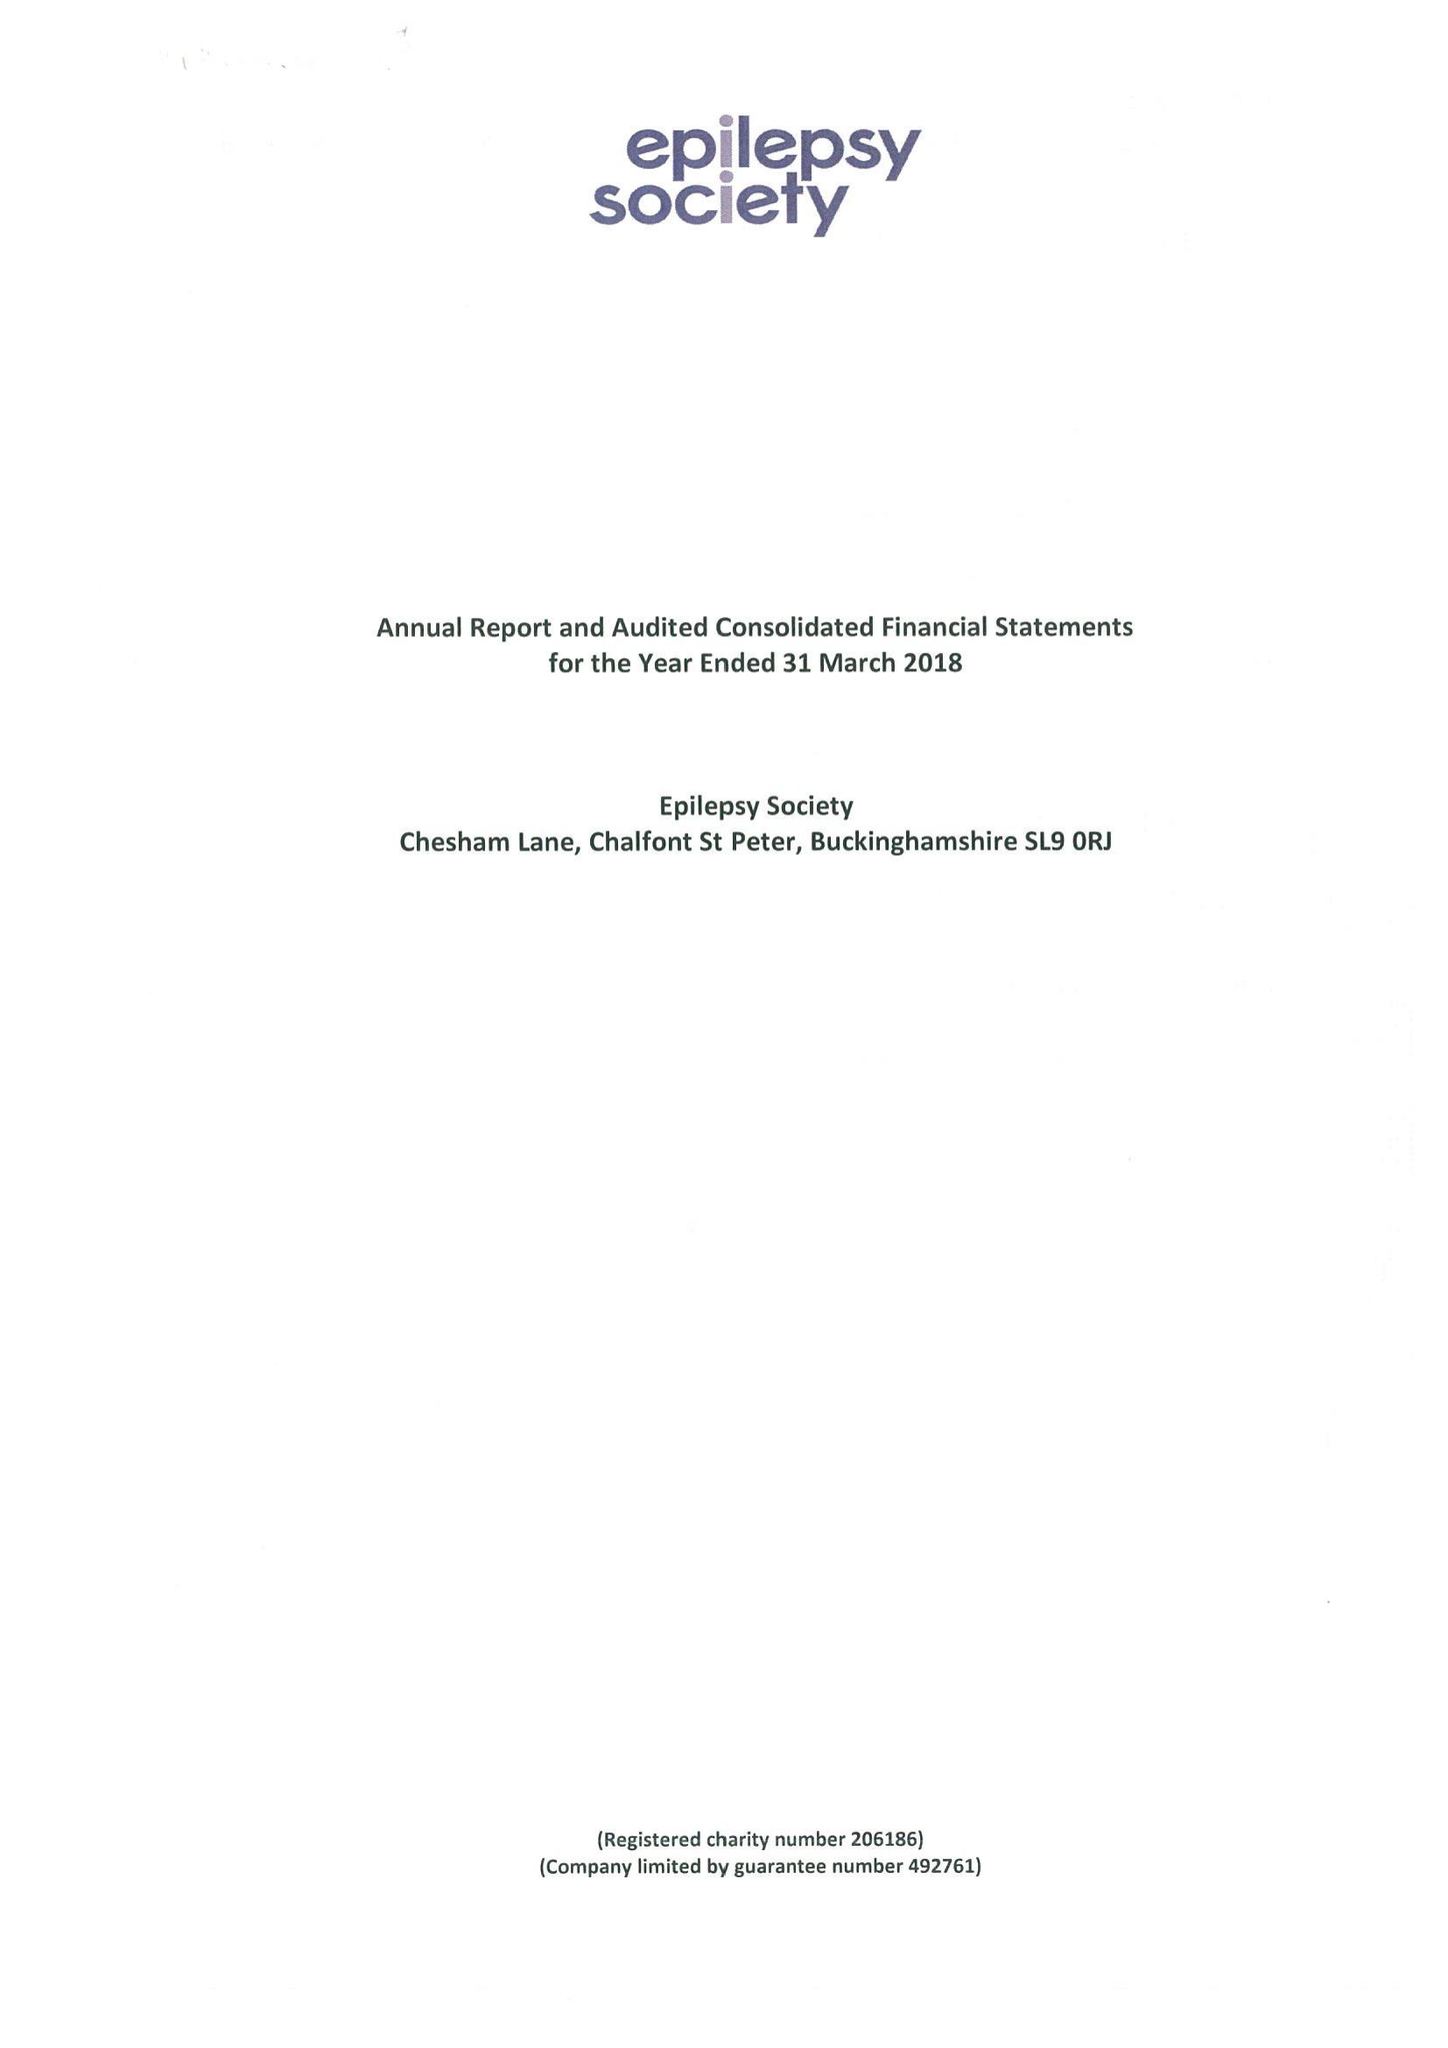What is the value for the report_date?
Answer the question using a single word or phrase. 2018-03-31 